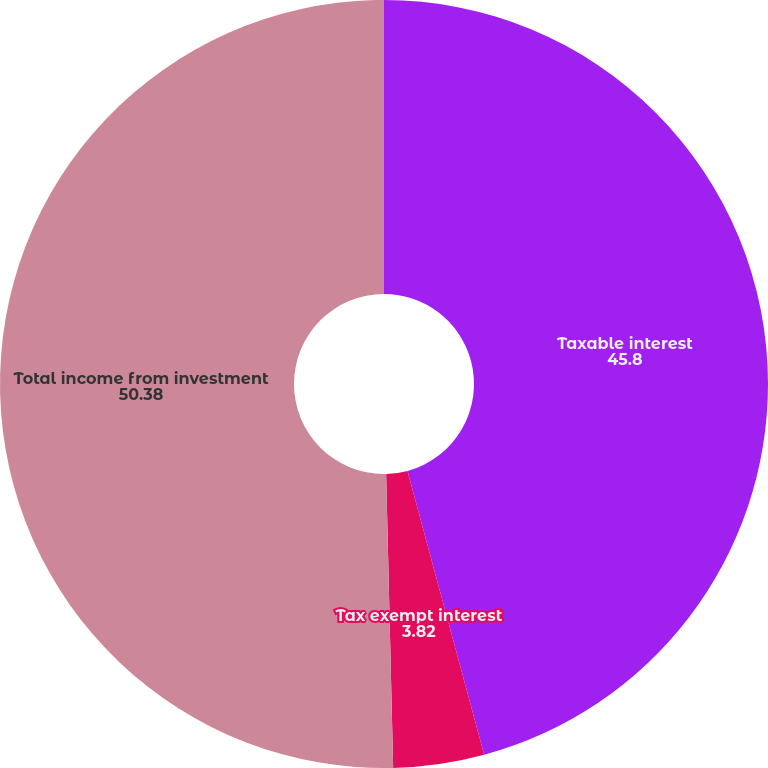<chart> <loc_0><loc_0><loc_500><loc_500><pie_chart><fcel>Taxable interest<fcel>Tax exempt interest<fcel>Total income from investment<nl><fcel>45.8%<fcel>3.82%<fcel>50.38%<nl></chart> 